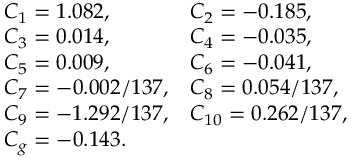<formula> <loc_0><loc_0><loc_500><loc_500>\begin{array} { l l } { { C _ { 1 } = 1 . 0 8 2 , } } & { { C _ { 2 } = - 0 . 1 8 5 , } } \\ { { C _ { 3 } = 0 . 0 1 4 , } } & { { C _ { 4 } = - 0 . 0 3 5 , } } \\ { { C _ { 5 } = 0 . 0 0 9 , } } & { { C _ { 6 } = - 0 . 0 4 1 , } } \\ { { C _ { 7 } = - 0 . 0 0 2 / 1 3 7 , } } & { { C _ { 8 } = 0 . 0 5 4 / 1 3 7 , } } \\ { { C _ { 9 } = - 1 . 2 9 2 / 1 3 7 , } } & { { C _ { 1 0 } = 0 . 2 6 2 / 1 3 7 , } } \\ { { C _ { g } = - 0 . 1 4 3 . } } \end{array}</formula> 